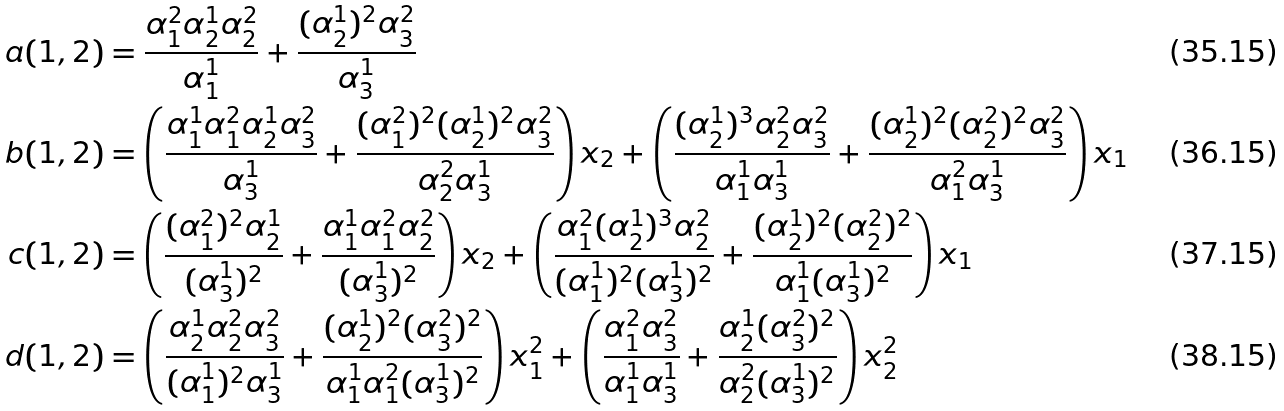Convert formula to latex. <formula><loc_0><loc_0><loc_500><loc_500>a ( 1 , 2 ) & = \frac { \alpha _ { 1 } ^ { 2 } \alpha _ { 2 } ^ { 1 } \alpha _ { 2 } ^ { 2 } } { \alpha _ { 1 } ^ { 1 } } + \frac { ( \alpha _ { 2 } ^ { 1 } ) ^ { 2 } \alpha _ { 3 } ^ { 2 } } { \alpha _ { 3 } ^ { 1 } } \\ b ( 1 , 2 ) & = \left ( \frac { \alpha _ { 1 } ^ { 1 } \alpha _ { 1 } ^ { 2 } \alpha _ { 2 } ^ { 1 } \alpha _ { 3 } ^ { 2 } } { \alpha _ { 3 } ^ { 1 } } + \frac { ( \alpha _ { 1 } ^ { 2 } ) ^ { 2 } ( \alpha _ { 2 } ^ { 1 } ) ^ { 2 } \alpha _ { 3 } ^ { 2 } } { \alpha _ { 2 } ^ { 2 } \alpha _ { 3 } ^ { 1 } } \right ) x _ { 2 } + \left ( \frac { ( \alpha _ { 2 } ^ { 1 } ) ^ { 3 } \alpha _ { 2 } ^ { 2 } \alpha _ { 3 } ^ { 2 } } { \alpha _ { 1 } ^ { 1 } \alpha _ { 3 } ^ { 1 } } + \frac { ( \alpha _ { 2 } ^ { 1 } ) ^ { 2 } ( \alpha _ { 2 } ^ { 2 } ) ^ { 2 } \alpha _ { 3 } ^ { 2 } } { \alpha _ { 1 } ^ { 2 } \alpha _ { 3 } ^ { 1 } } \right ) x _ { 1 } \\ c ( 1 , 2 ) & = \left ( \frac { ( \alpha _ { 1 } ^ { 2 } ) ^ { 2 } \alpha _ { 2 } ^ { 1 } } { ( \alpha _ { 3 } ^ { 1 } ) ^ { 2 } } + \frac { \alpha _ { 1 } ^ { 1 } \alpha _ { 1 } ^ { 2 } \alpha _ { 2 } ^ { 2 } } { ( \alpha _ { 3 } ^ { 1 } ) ^ { 2 } } \right ) x _ { 2 } + \left ( \frac { \alpha _ { 1 } ^ { 2 } ( \alpha _ { 2 } ^ { 1 } ) ^ { 3 } \alpha _ { 2 } ^ { 2 } } { ( \alpha _ { 1 } ^ { 1 } ) ^ { 2 } ( \alpha _ { 3 } ^ { 1 } ) ^ { 2 } } + \frac { ( \alpha _ { 2 } ^ { 1 } ) ^ { 2 } ( \alpha _ { 2 } ^ { 2 } ) ^ { 2 } } { \alpha _ { 1 } ^ { 1 } ( \alpha _ { 3 } ^ { 1 } ) ^ { 2 } } \right ) x _ { 1 } \\ d ( 1 , 2 ) & = \left ( \frac { \alpha _ { 2 } ^ { 1 } \alpha _ { 2 } ^ { 2 } \alpha _ { 3 } ^ { 2 } } { ( \alpha _ { 1 } ^ { 1 } ) ^ { 2 } \alpha _ { 3 } ^ { 1 } } + \frac { ( \alpha _ { 2 } ^ { 1 } ) ^ { 2 } ( \alpha _ { 3 } ^ { 2 } ) ^ { 2 } } { \alpha _ { 1 } ^ { 1 } \alpha _ { 1 } ^ { 2 } ( \alpha _ { 3 } ^ { 1 } ) ^ { 2 } } \right ) x _ { 1 } ^ { 2 } + \left ( \frac { \alpha _ { 1 } ^ { 2 } \alpha _ { 3 } ^ { 2 } } { \alpha _ { 1 } ^ { 1 } \alpha _ { 3 } ^ { 1 } } + \frac { \alpha _ { 2 } ^ { 1 } ( \alpha _ { 3 } ^ { 2 } ) ^ { 2 } } { \alpha _ { 2 } ^ { 2 } ( \alpha _ { 3 } ^ { 1 } ) ^ { 2 } } \right ) x _ { 2 } ^ { 2 }</formula> 